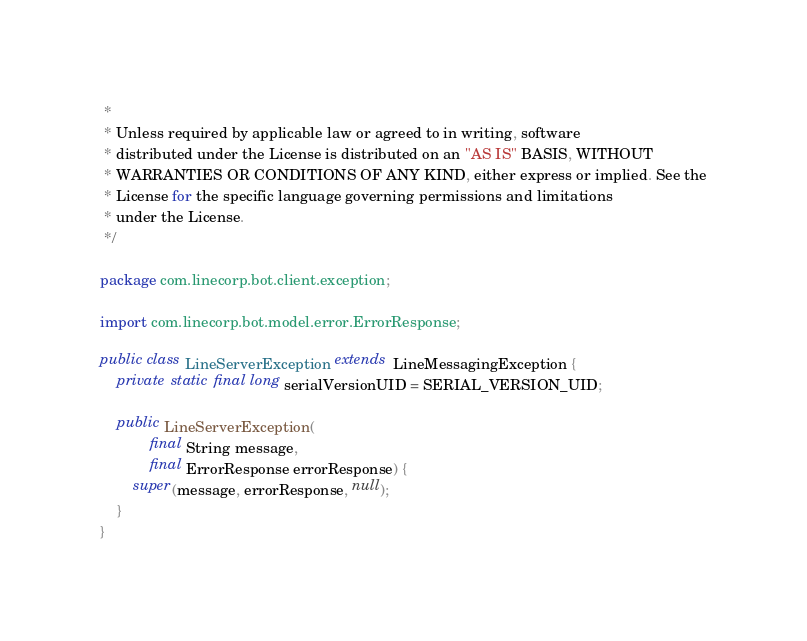<code> <loc_0><loc_0><loc_500><loc_500><_Java_> *
 * Unless required by applicable law or agreed to in writing, software
 * distributed under the License is distributed on an "AS IS" BASIS, WITHOUT
 * WARRANTIES OR CONDITIONS OF ANY KIND, either express or implied. See the
 * License for the specific language governing permissions and limitations
 * under the License.
 */

package com.linecorp.bot.client.exception;

import com.linecorp.bot.model.error.ErrorResponse;

public class LineServerException extends LineMessagingException {
    private static final long serialVersionUID = SERIAL_VERSION_UID;

    public LineServerException(
            final String message,
            final ErrorResponse errorResponse) {
        super(message, errorResponse, null);
    }
}
</code> 